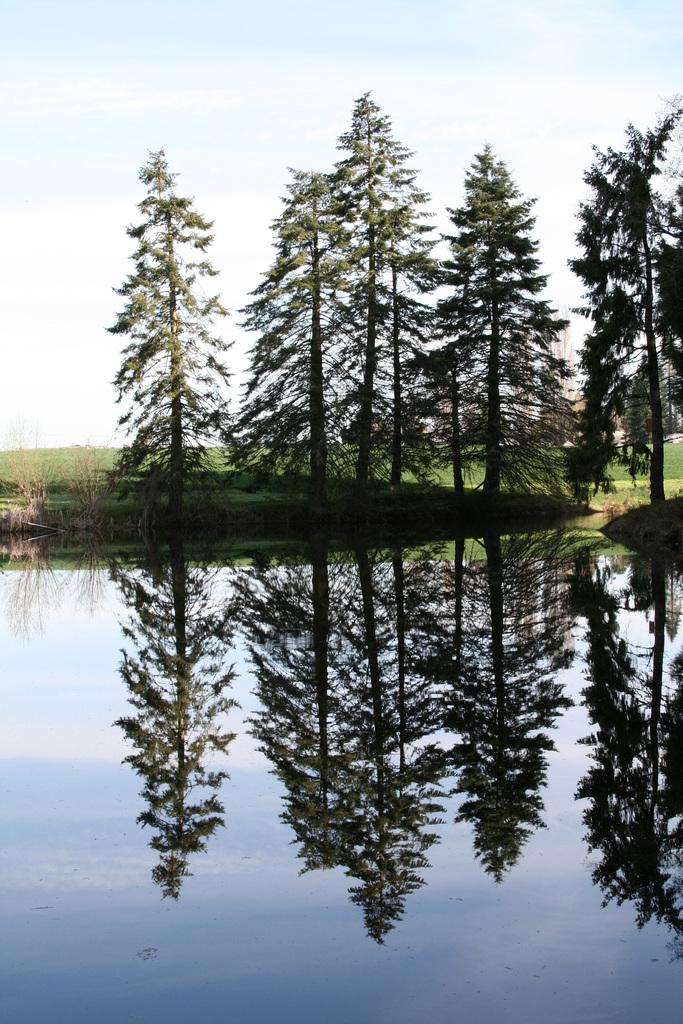What type of natural feature can be seen in the image? There is a water body in the image. What other natural elements are present in the image? There are plants, grass, and a group of trees in the image. What is the condition of the sky in the image? The sky is visible in the image, and it looks cloudy. What is the group of trees' belief about the motion of the water body in the image? There is no indication in the image that the group of trees has any beliefs, as trees do not have the ability to form beliefs. Additionally, the water body is not in motion in the image. 